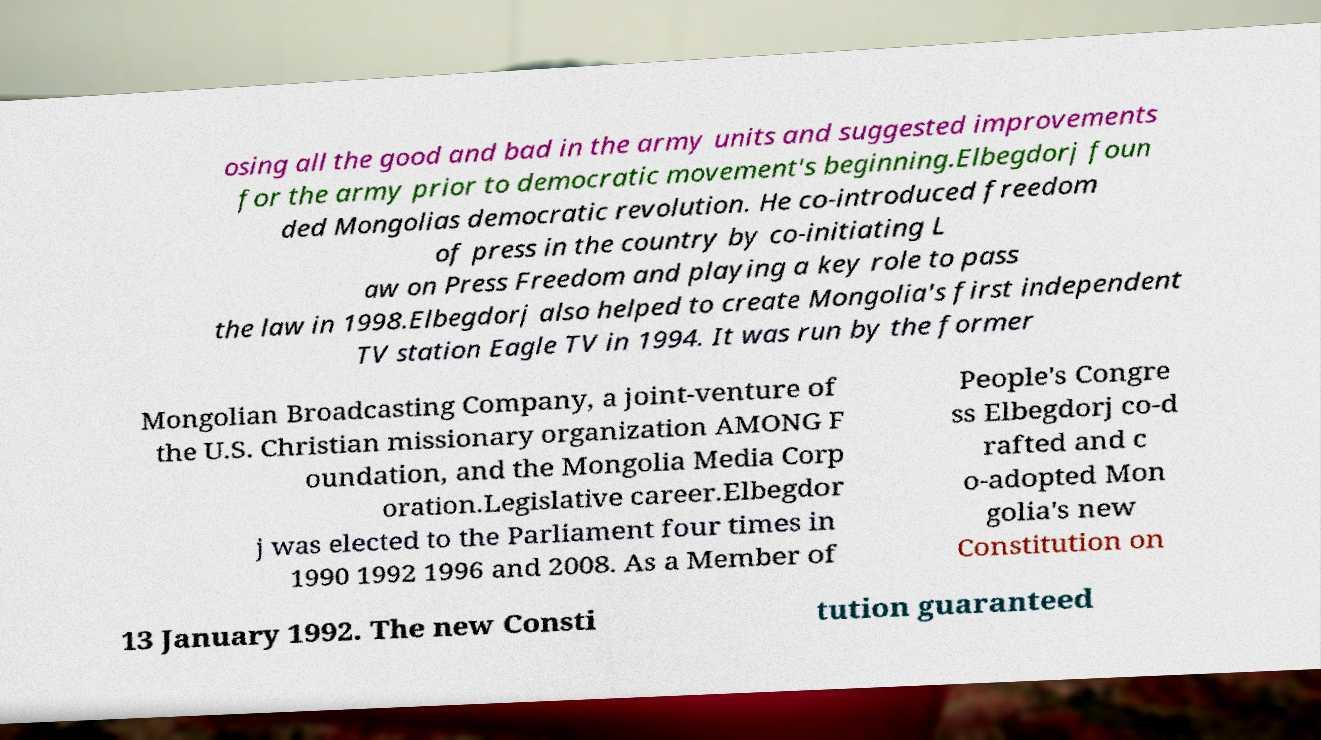There's text embedded in this image that I need extracted. Can you transcribe it verbatim? osing all the good and bad in the army units and suggested improvements for the army prior to democratic movement's beginning.Elbegdorj foun ded Mongolias democratic revolution. He co-introduced freedom of press in the country by co-initiating L aw on Press Freedom and playing a key role to pass the law in 1998.Elbegdorj also helped to create Mongolia's first independent TV station Eagle TV in 1994. It was run by the former Mongolian Broadcasting Company, a joint-venture of the U.S. Christian missionary organization AMONG F oundation, and the Mongolia Media Corp oration.Legislative career.Elbegdor j was elected to the Parliament four times in 1990 1992 1996 and 2008. As a Member of People's Congre ss Elbegdorj co-d rafted and c o-adopted Mon golia's new Constitution on 13 January 1992. The new Consti tution guaranteed 